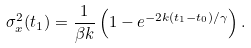<formula> <loc_0><loc_0><loc_500><loc_500>\sigma _ { x } ^ { 2 } ( t _ { 1 } ) = \frac { 1 } { \beta k } \left ( 1 - e ^ { - 2 k ( t _ { 1 } - t _ { 0 } ) / \gamma } \right ) .</formula> 